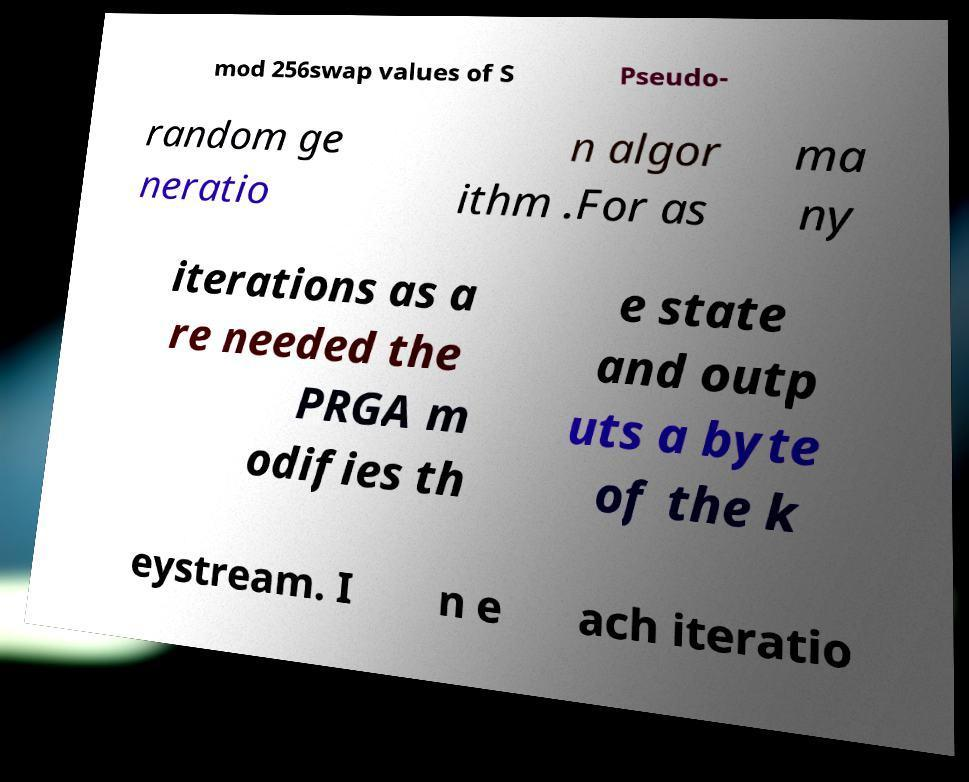Can you read and provide the text displayed in the image?This photo seems to have some interesting text. Can you extract and type it out for me? mod 256swap values of S Pseudo- random ge neratio n algor ithm .For as ma ny iterations as a re needed the PRGA m odifies th e state and outp uts a byte of the k eystream. I n e ach iteratio 